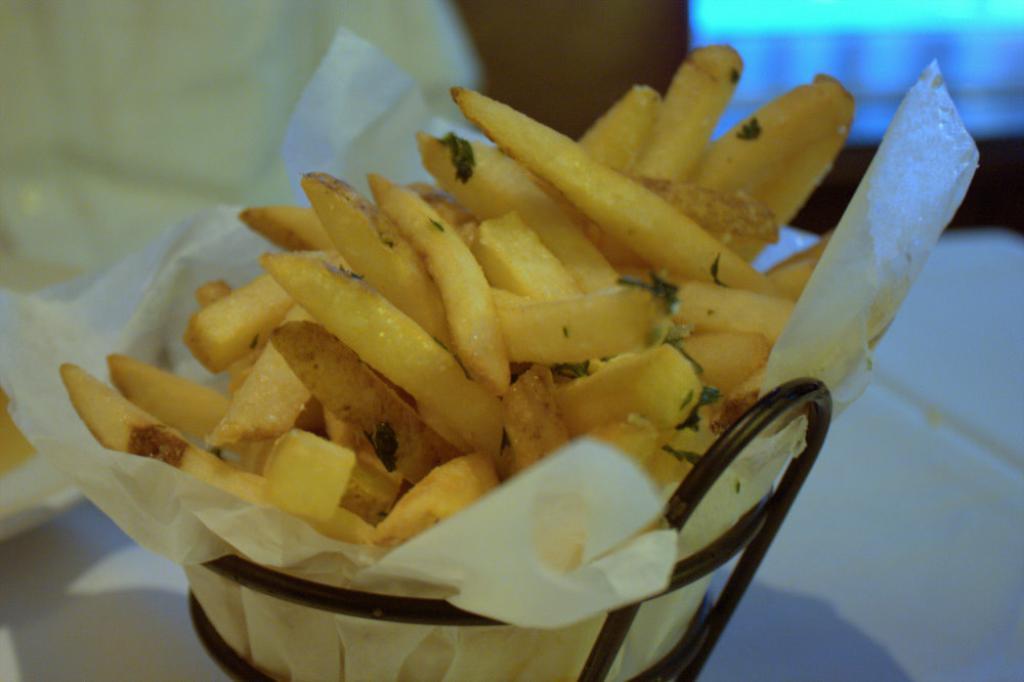Can you describe this image briefly? At the bottom of the image we can see a table, on the table we can see a bowl. In the bowl we can see some french fries and paper. In the top left corner of the image we can see a person. Background of the image is blur. 